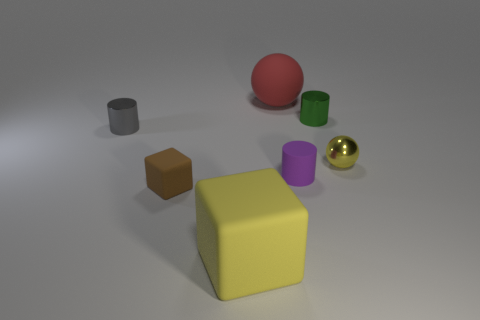Subtract all small green cylinders. How many cylinders are left? 2 Add 2 gray shiny cylinders. How many objects exist? 9 Subtract all green cylinders. How many cylinders are left? 2 Subtract all blocks. How many objects are left? 5 Subtract 1 cubes. How many cubes are left? 1 Subtract all red spheres. Subtract all green blocks. How many spheres are left? 1 Subtract all small green metallic objects. Subtract all yellow rubber blocks. How many objects are left? 5 Add 4 matte spheres. How many matte spheres are left? 5 Add 7 red balls. How many red balls exist? 8 Subtract 0 purple balls. How many objects are left? 7 